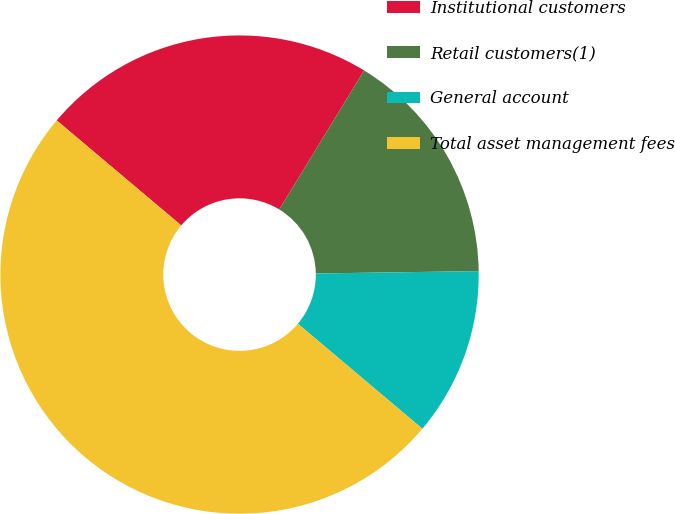Convert chart. <chart><loc_0><loc_0><loc_500><loc_500><pie_chart><fcel>Institutional customers<fcel>Retail customers(1)<fcel>General account<fcel>Total asset management fees<nl><fcel>22.57%<fcel>16.05%<fcel>11.38%<fcel>50.0%<nl></chart> 